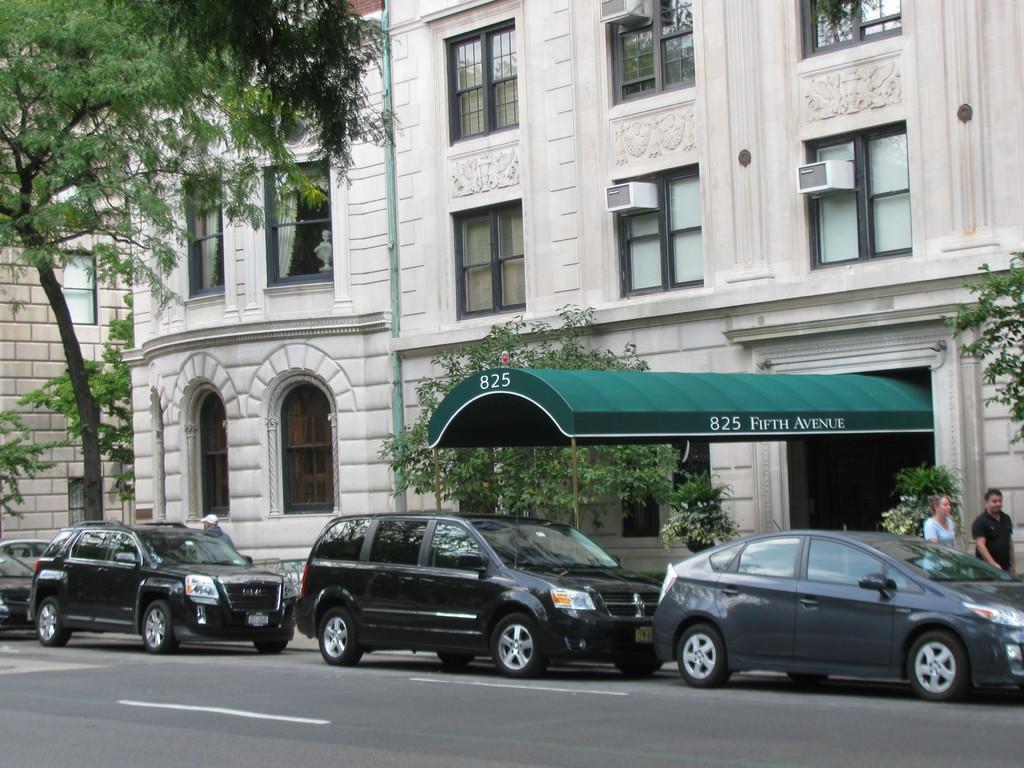Describe this image in one or two sentences. In this image, there are cars on the road. I can see a building and there are trees. On the right side of the image, there are two persons standing. 